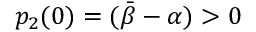Convert formula to latex. <formula><loc_0><loc_0><loc_500><loc_500>p _ { 2 } ( 0 ) = ( \bar { \beta } - { \alpha } ) > 0</formula> 